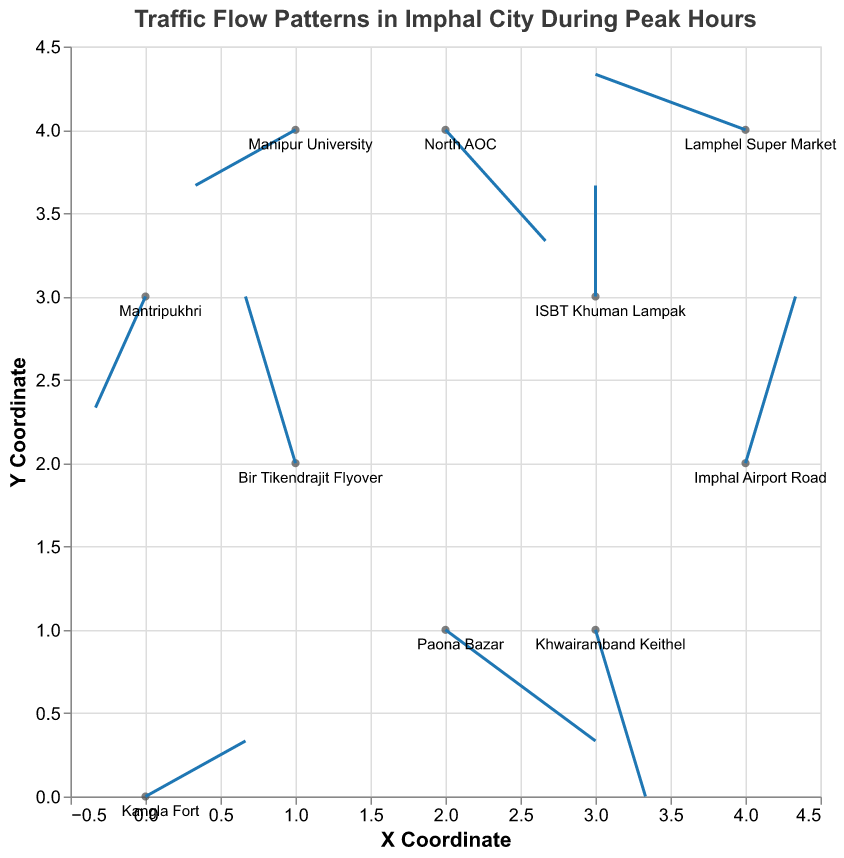What does the title of the figure indicate? The title of the figure, "Traffic Flow Patterns in Imphal City During Peak Hours," suggests the plot is analyzing and displaying the direction and magnitude of traffic flow across different locations in Imphal city during peak hours.
Answer: Traffic Flow Patterns in Imphal City During Peak Hours How many data points are depicted in the plot? To determine the number of data points, we count the plotted locations' coordinates in the figure. Each location has a unique coordinate and direction vector. In this case, there are 10 different locations shown.
Answer: 10 Which location has the highest vertical traffic flow component? To find the location with the highest vertical component (v), examine the values for the vertical component listed for each location. "Bir Tikendrajit Flyover" has the highest vertical component of v = 3.
Answer: Bir Tikendrajit Flyover In which direction is the traffic near "Paona Bazar" moving? The traffic direction can be determined from the vector components (u, v) at Paona Bazar (2,1). Here, the traffic vector is (3, -2), indicating movement to the right and downward (south-east direction).
Answer: South-East What is the average horizontal traffic component (u) for all locations? To find the average horizontal component, sum up all horizontal components and divide by the number of locations. Total u = 2 + (-1) + 3 + 0 + (-2) + 1 + 2 + (-3) + 1 + (-1) which is 2. Since there are 10 locations, the average is 2 / 10 = 0.2.
Answer: 0.2 Which locations have traffic flow vectors pointing downwards? Traffic flows downwards if the vertical component (v) is negative. The locations with negative vertical components are "Paona Bazar" (v = -2), "North AOC" (v = -2), "Khwairamband Keithel" (v = -3), and "Mantripukhri" (v = -2).
Answer: Paona Bazar, North AOC, Khwairamband Keithel, Mantripukhri What is the traffic magnitude at "Imphal Airport Road"? The magnitude of the traffic vector can be calculated using the Pythagorean theorem on its components (u, v). For "Imphal Airport Road" (1, 3), the magnitude is sqrt(1^2 + 3^2) = sqrt(1 + 9) = sqrt(10).
Answer: sqrt(10) Compare the traffic flow vectors at "Kangla Fort" and "Manipur University." Which has a greater magnitude? Calculate the magnitudes: 
"Kangla Fort" (2, 1) has a magnitude sqrt(2^2 + 1^2) = sqrt(4 + 1) = sqrt(5).
"Manipur University" (-2, -1) has a magnitude sqrt((-2)^2 + (-1)^2) = sqrt(4 + 1) = sqrt(5).
Both locations have an equal magnitude of sqrt(5).
Answer: Equal What is the net vertical traffic flow component across all locations? Sum up all the vertical components (v): 1 + 3 + (-2) + 2 + (-1) + 3 + (-2) + 1 + (-3) + (-2) = 0. The net vertical component is 0.
Answer: 0 Which location has the largest vector angle deviation from the horizontal axis? The vector angle can be found using the arctan function on the components (u, v). The location with the most significant vertical component usually has the largest deviation. Here, "Bir Tikendrajit Flyover" with (u = -1, v = 3) has the largest vertical component. The angle θ = arctan(3 / -1) = arctan(-3), showing a significant deviation.
Answer: Bir Tikendrajit Flyover 